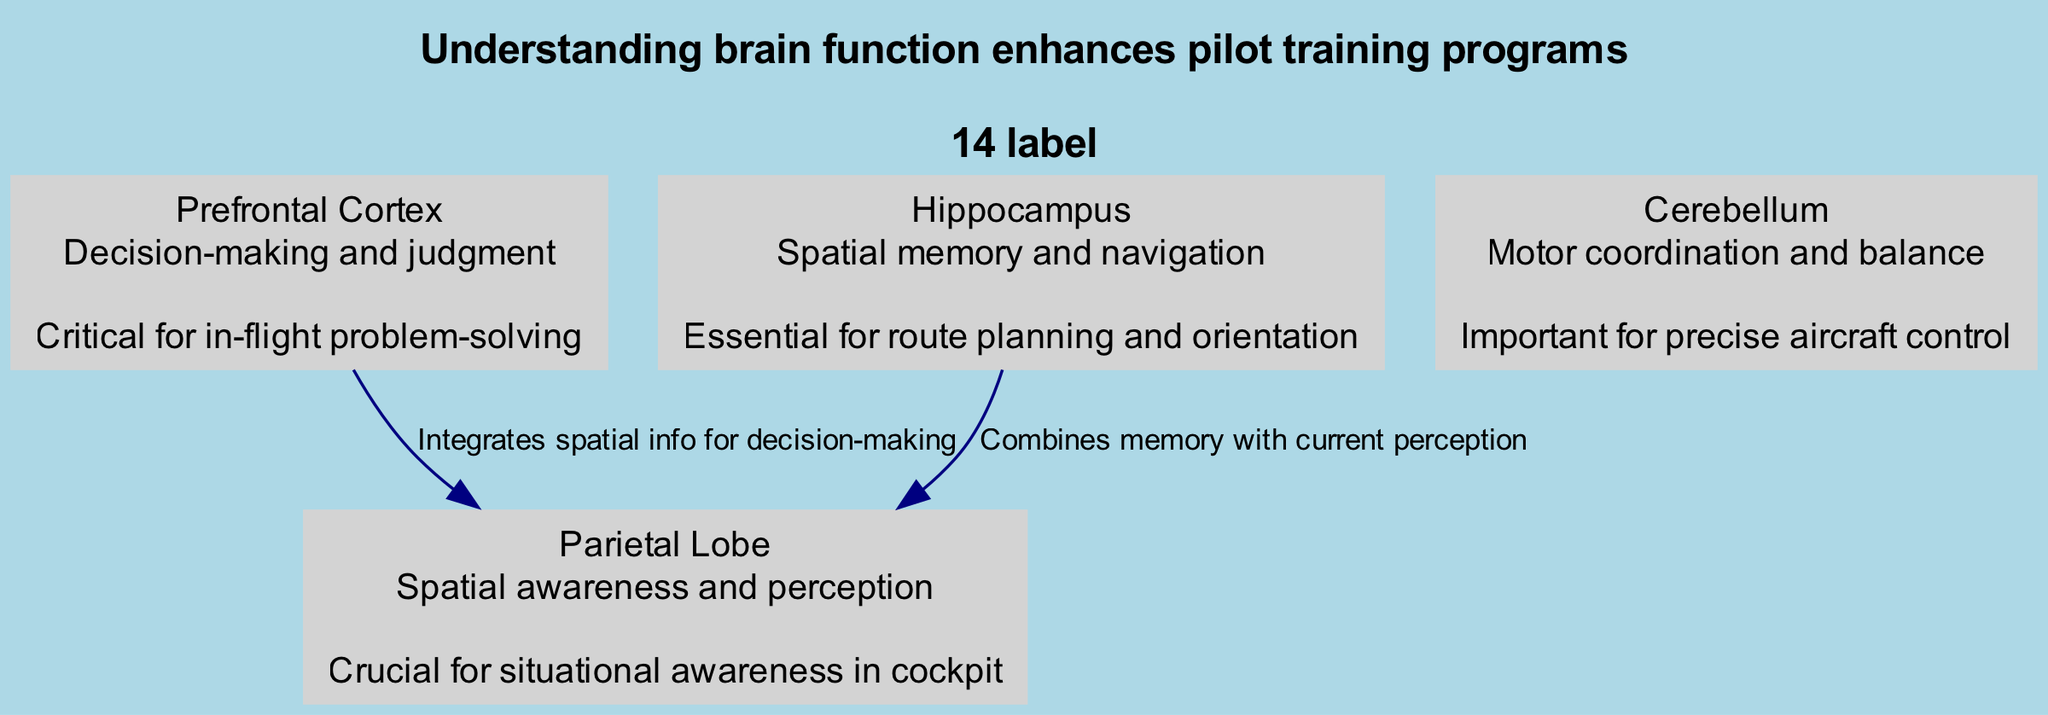What is the role of the Hippocampus? The diagram indicates that the Hippocampus is responsible for spatial memory and navigation. This is further detailed in its relevance, where it states that it's essential for route planning and orientation.
Answer: Spatial memory and navigation How many main components are depicted in the diagram? The diagram lists four main components: Prefrontal Cortex, Hippocampus, Parietal Lobe, and Cerebellum. Thus, counting them, we find that there are four components.
Answer: 4 Which brain region integrates spatial information for decision-making? According to the connections shown in the diagram, the arrow from the Prefrontal Cortex to the Parietal Lobe specifies that the Prefrontal Cortex integrates spatial information for decision-making.
Answer: Prefrontal Cortex What function is associated with the Cerebellum? The diagram indicates that the Cerebellum is responsible for motor coordination and balance. This is also connected to its relevance, which states its importance for precise aircraft control.
Answer: Motor coordination and balance What are the two brain regions that connect via the Hippocampus? The diagram shows an edge from the Hippocampus to the Parietal Lobe. It highlights that the Hippocampus combines memory with current perception, linking these two regions.
Answer: Hippocampus and Parietal Lobe Which component is critical for in-flight problem-solving? The diagram describes the Prefrontal Cortex as critical for in-flight problem-solving due to its function related to decision-making and judgment detailed in the diagram.
Answer: Prefrontal Cortex What does the bottom additional information state? Located at the bottom of the diagram, the additional information states that these brain regions work together to support safe and effective piloting.
Answer: These brain regions work together to support safe and effective piloting How are the components related to situational awareness in the cockpit? The diagram indicates that the Parietal Lobe is crucial for situational awareness in the cockpit by emphasizing its function in spatial awareness and perception, connecting it to the other components involved in decision-making.
Answer: Parietal Lobe 